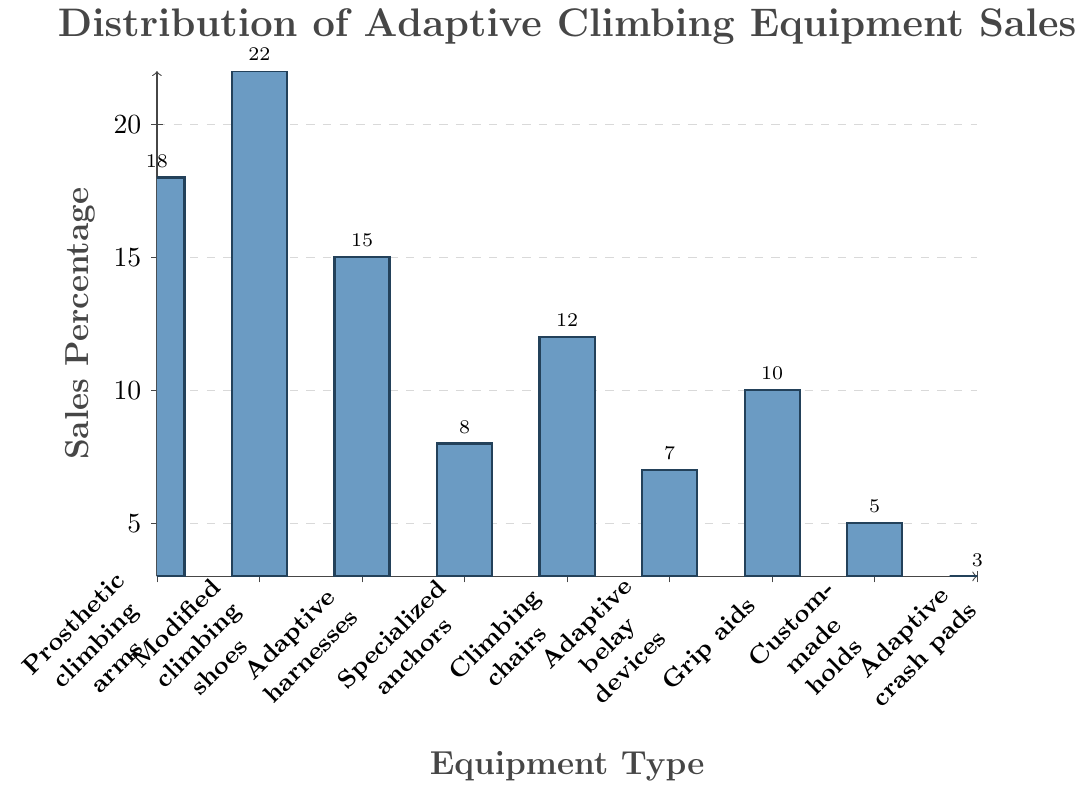Which type of equipment has the highest sales percentage? By examining the heights of the bars, the tallest bar represents "Modified Climbing Shoes" with a sales percentage of 22%.
Answer: Modified Climbing Shoes Which type of equipment has the lowest sales percentage? The shortest bar corresponds to "Adaptive Crash Pads" with a sales percentage of 3%.
Answer: Adaptive Crash Pads What is the combined sales percentage of "Prosthetic Climbing Arms" and "Grip Aids"? The sales percentage of "Prosthetic Climbing Arms" is 18% and "Grip Aids" is 10%. Adding these together: 18% + 10% = 28%.
Answer: 28% What is the difference in sales percentage between "Modified Climbing Shoes" and "Adaptive Belay Devices"? "Modified Climbing Shoes" have a sales percentage of 22% and "Adaptive Belay Devices" have 7%. The difference is 22% - 7% = 15%.
Answer: 15% Which equipment types have a sales percentage equal to or greater than 15%? Equipment types with sales percentages of 15% or more are: "Prosthetic Climbing Arms" (18%), "Modified Climbing Shoes" (22%), and "Adaptive Harnesses" (15%).
Answer: Prosthetic Climbing Arms, Modified Climbing Shoes, Adaptive Harnesses What is the average sales percentage of "Specialized Anchors," "Climbing Chairs," and "Custom-made Holds"? The sales percentages are 8%, 12%, and 5%, respectively. Adding these: 8% + 12% + 5% = 25%. Dividing by 3, the average is 25% / 3 ≈ 8.33%.
Answer: 8.33% What is the total sales percentage of all listed equipment types? Summing all the percentages: 18% + 22% + 15% + 8% + 12% + 7% + 10% + 5% + 3% = 100%.
Answer: 100% Which equipment type has a sales percentage closest to 10%? "Grip Aids" have a sales percentage of exactly 10%.
Answer: Grip Aids Is the sales percentage of "Adaptive Harnesses" greater than that of "Climbing Chairs"? The sales percentage of "Adaptive Harnesses" is 15%, while "Climbing Chairs" is 12%. 15% is greater than 12%.
Answer: Yes 